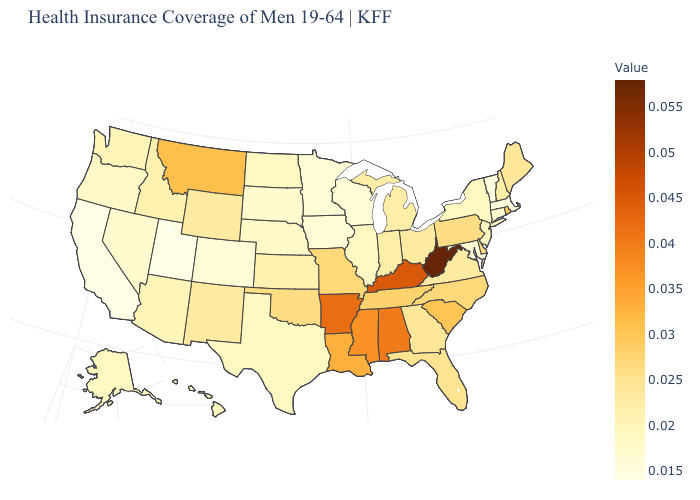Which states have the lowest value in the USA?
Short answer required. California, Utah. Which states have the lowest value in the West?
Write a very short answer. California, Utah. Does California have the lowest value in the West?
Be succinct. Yes. Does Michigan have the highest value in the MidWest?
Write a very short answer. No. Does Hawaii have a higher value than Arkansas?
Quick response, please. No. Does Mississippi have the lowest value in the USA?
Be succinct. No. Which states have the lowest value in the USA?
Quick response, please. California, Utah. Which states have the lowest value in the Northeast?
Give a very brief answer. Massachusetts, Vermont. Which states have the highest value in the USA?
Keep it brief. West Virginia. 